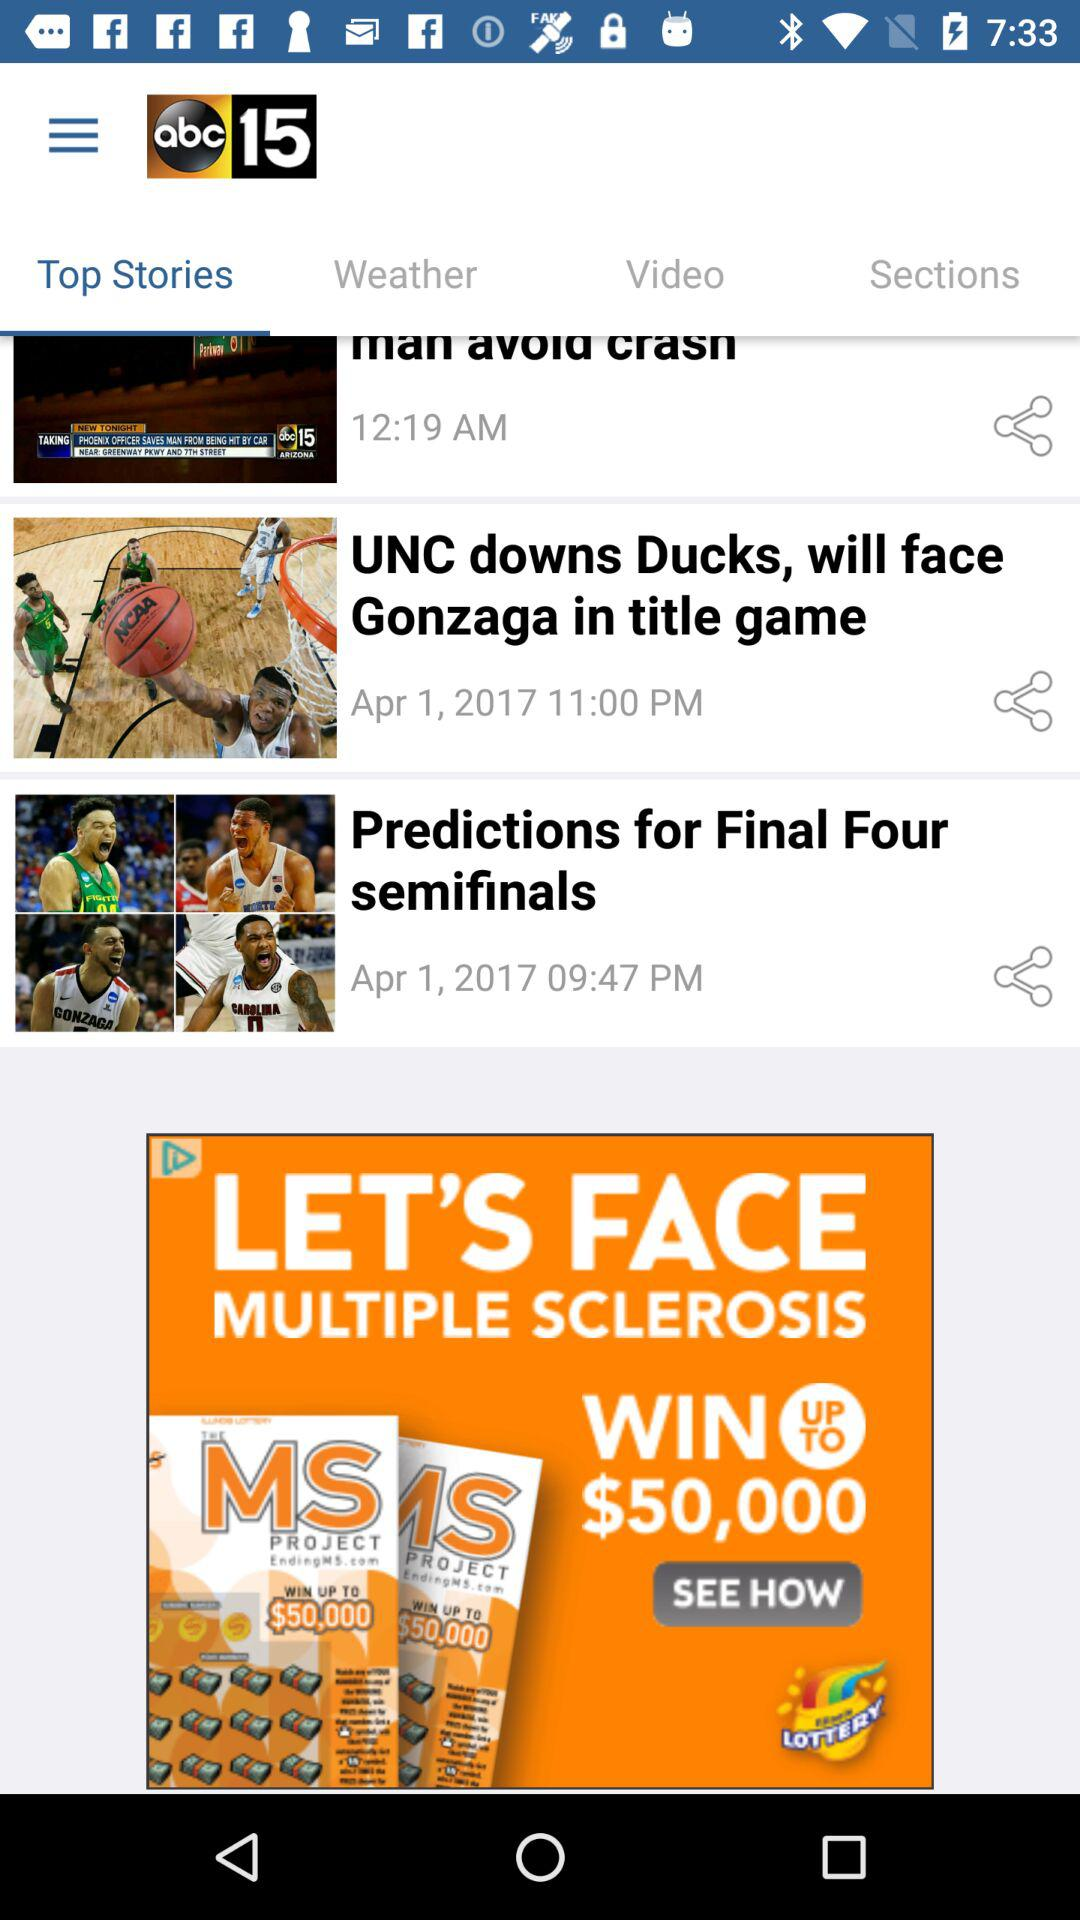Which headline was published at 11:00 PM? The headline that was published at 11:00 PM was "UNC downs Ducks, will face Gonzaga in title game". 